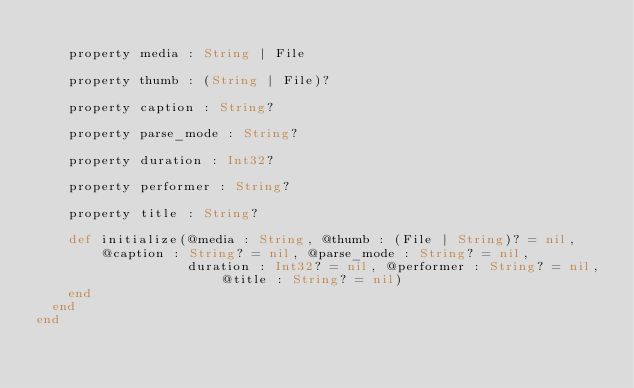Convert code to text. <code><loc_0><loc_0><loc_500><loc_500><_Crystal_>
    property media : String | File

    property thumb : (String | File)?

    property caption : String?

    property parse_mode : String?

    property duration : Int32?

    property performer : String?

    property title : String?

    def initialize(@media : String, @thumb : (File | String)? = nil, @caption : String? = nil, @parse_mode : String? = nil,
                   duration : Int32? = nil, @performer : String? = nil, @title : String? = nil)
    end
  end
end
</code> 